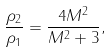<formula> <loc_0><loc_0><loc_500><loc_500>\frac { \rho _ { 2 } } { \rho _ { 1 } } = \frac { 4 M ^ { 2 } } { M ^ { 2 } + 3 } ,</formula> 